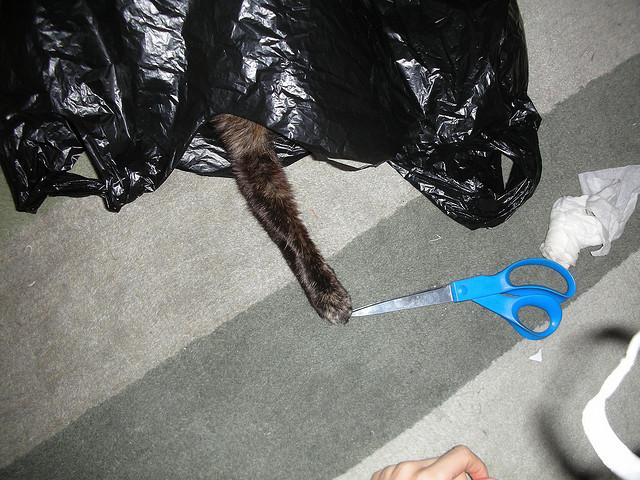Is that a paw of a cat?
Give a very brief answer. Yes. How many hands are in the picture?
Concise answer only. 1. What color is the scissors?
Keep it brief. Blue. 